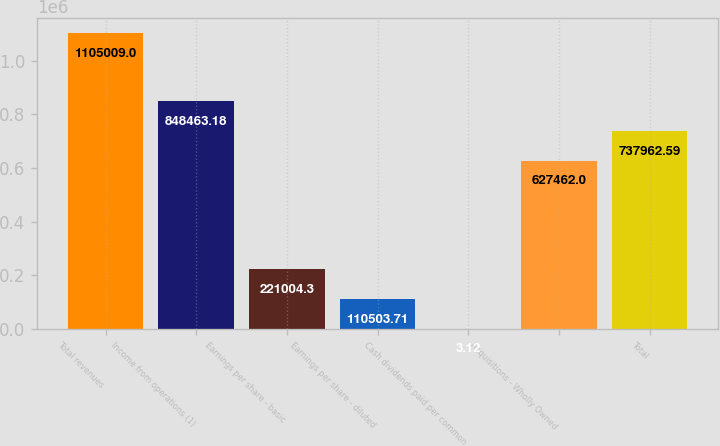Convert chart. <chart><loc_0><loc_0><loc_500><loc_500><bar_chart><fcel>Total revenues<fcel>Income from operations (1)<fcel>Earnings per share - basic<fcel>Earnings per share - diluted<fcel>Cash dividends paid per common<fcel>Acquisitions - Wholly Owned<fcel>Total<nl><fcel>1.10501e+06<fcel>848463<fcel>221004<fcel>110504<fcel>3.12<fcel>627462<fcel>737963<nl></chart> 